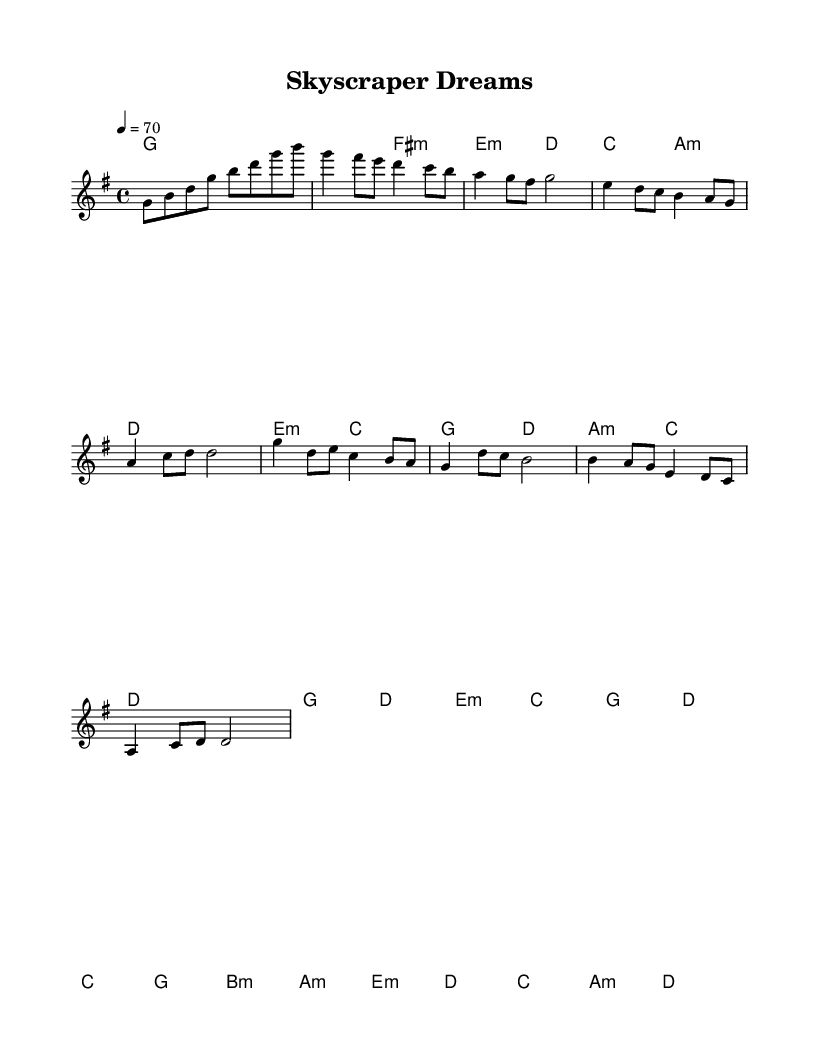What is the key signature of this music? The key signature indicated at the beginning of the sheet music is G major, which has one sharp (F#).
Answer: G major What is the time signature of this music? The time signature shown at the start of the music is 4/4, meaning there are four beats per measure.
Answer: 4/4 What is the tempo marking for this piece? The tempo marking indicates a speed of 70 beats per minute, signaling a moderate pace for the piece.
Answer: 70 How many measures are there in the chorus section? By counting the measures in the chorus segment of the sheet music, there are a total of four measures: two measures of four beats followed by two measures of two beats.
Answer: 4 What type of harmony is primarily used in the verse section? The harmonies in the verse section primarily consist of G major, E minor, A minor, and D major chords, creating a reflective atmosphere typical in K-Pop ballads.
Answer: Triadic harmony What musical form does this piece follow? The overall structure of the piece, particularly the repetition of sections and the clear division into verses, pre-choruses, choruses, and a bridge, reflects a common pop song format known as AABA or verse-chorus.
Answer: Verse-Chorus Structure Which section contains the highest melodic note? The highest note in the melody occurs in the chorus section where it reaches D, indicating a peak in the emotional intensity of the ballad.
Answer: Chorus 